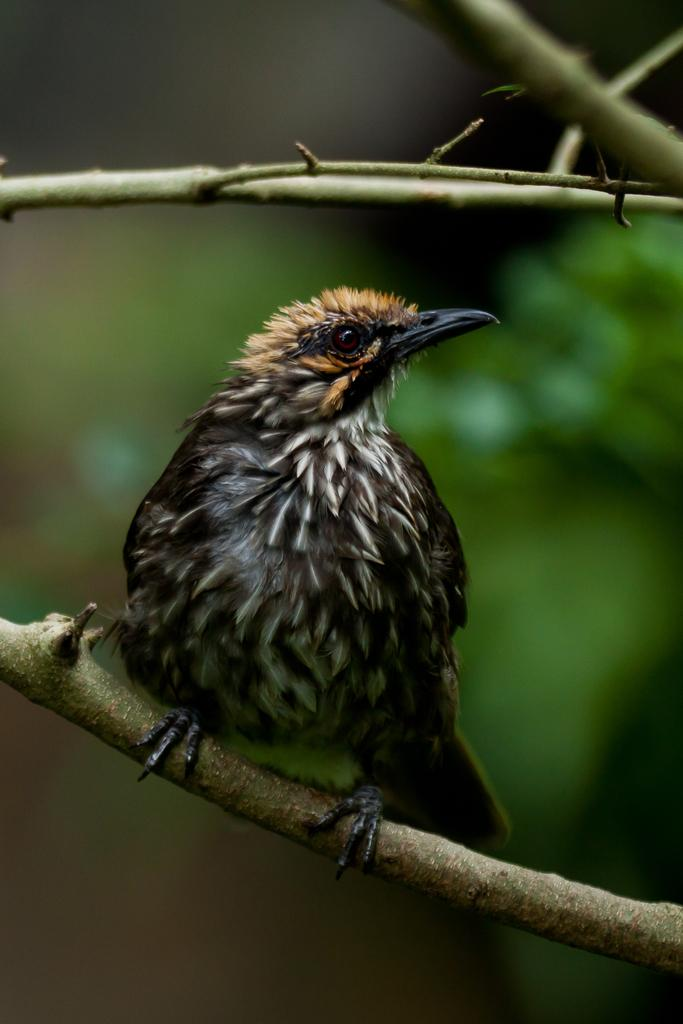What type of animal is in the image? There is a bird in the image. What colors can be seen on the bird? The bird has white, black, and light brown colors. Where is the bird located in the image? The bird is sitting on a tree branch. How would you describe the background of the image? The background of the image is blurred. What type of brass instrument is being played in the background of the image? There is no brass instrument or any indication of music being played in the image; it features a bird sitting on a tree branch. Can you see the moon in the image? The moon is not visible in the image; it only shows a bird on a tree branch with a blurred background. 